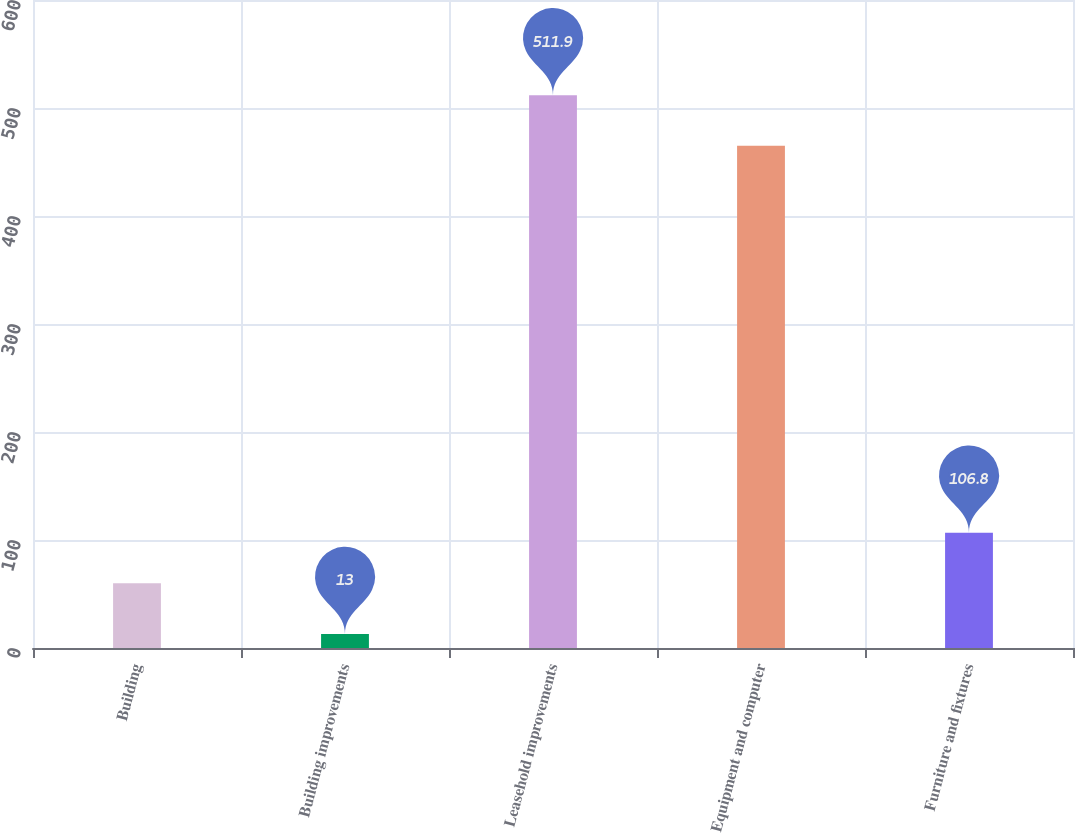<chart> <loc_0><loc_0><loc_500><loc_500><bar_chart><fcel>Building<fcel>Building improvements<fcel>Leasehold improvements<fcel>Equipment and computer<fcel>Furniture and fixtures<nl><fcel>59.9<fcel>13<fcel>511.9<fcel>465<fcel>106.8<nl></chart> 